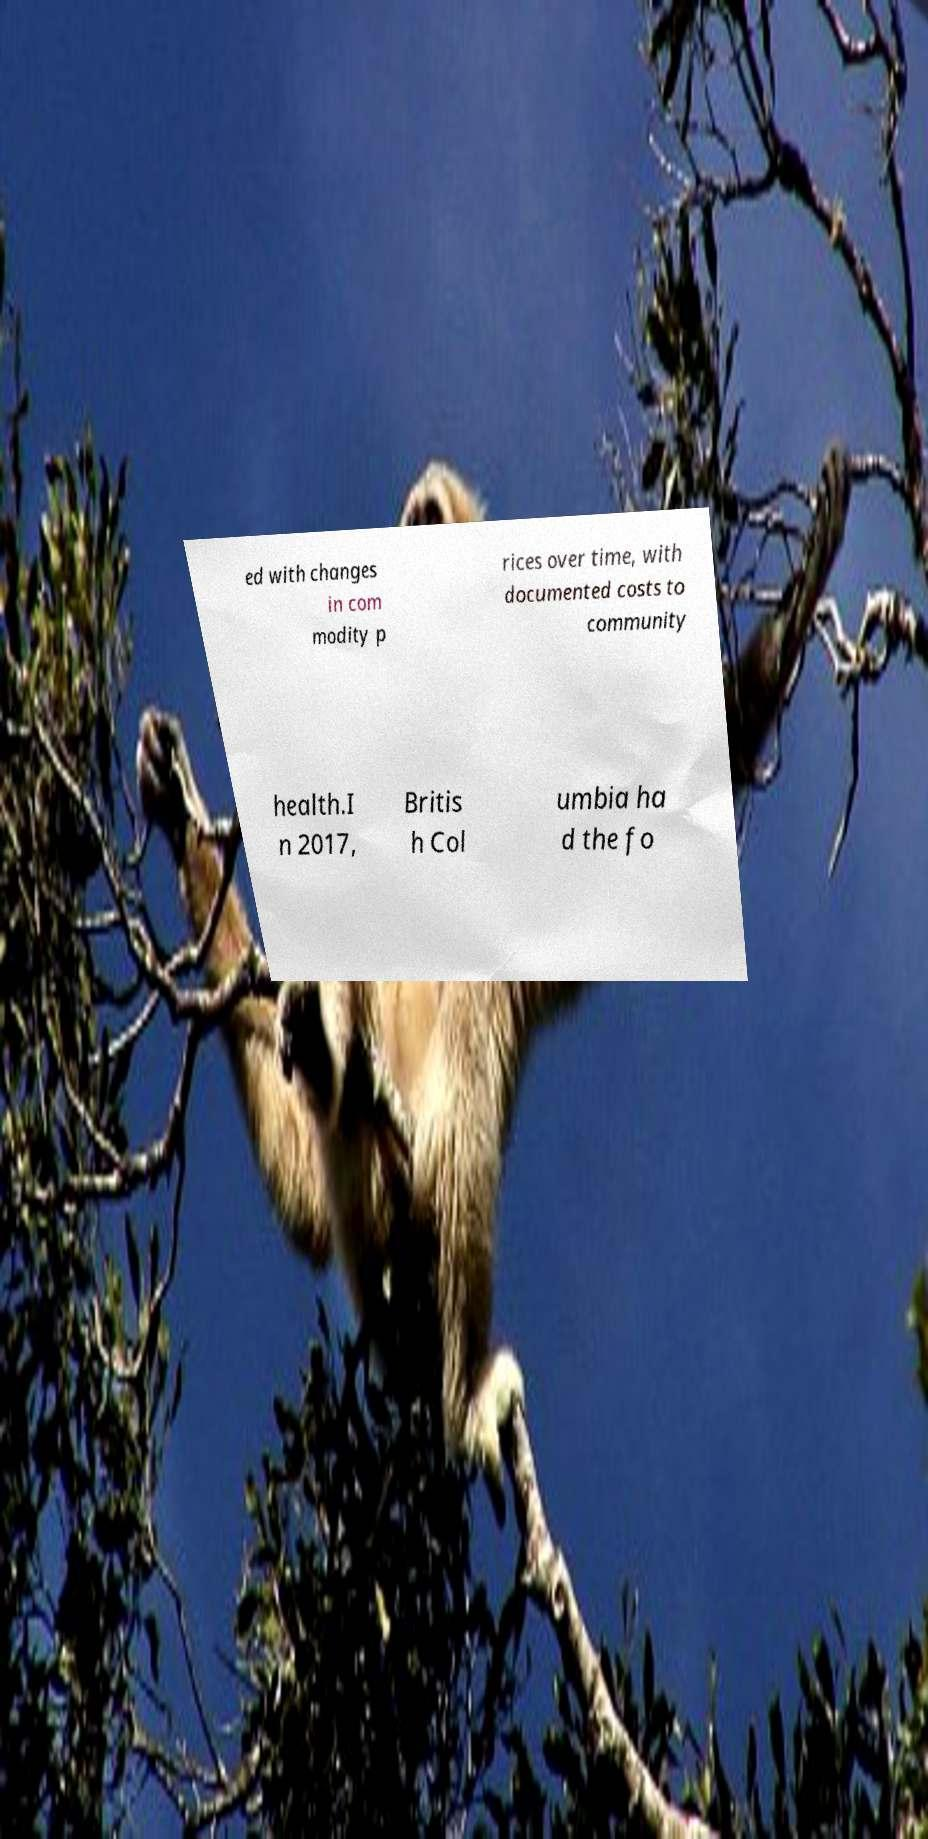Please identify and transcribe the text found in this image. ed with changes in com modity p rices over time, with documented costs to community health.I n 2017, Britis h Col umbia ha d the fo 